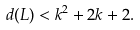<formula> <loc_0><loc_0><loc_500><loc_500>d ( L ) < k ^ { 2 } + 2 k + 2 .</formula> 